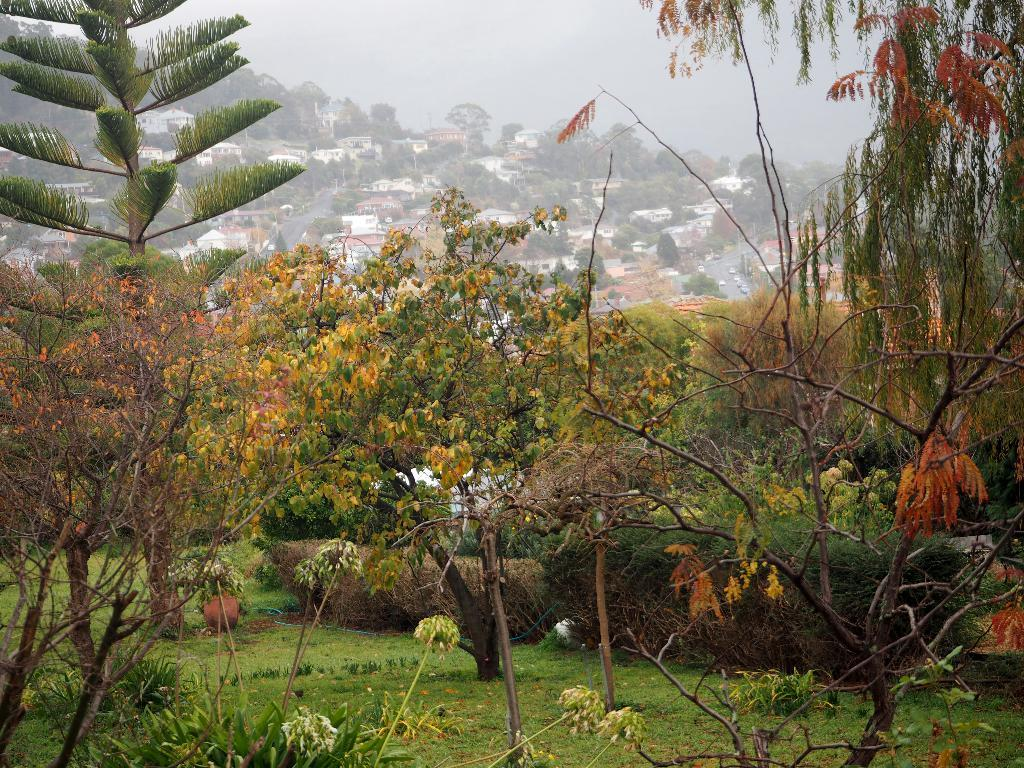What type of vegetation can be seen in the image? There are trees, plants, and grass in the image. What type of landscape feature is present in the image? There are hills in the image. Are there any man-made structures visible in the image? Yes, there are houses in the image. What is visible at the top of the image? The sky is visible at the top of the image. What type of square is depicted in the image? There is no square present in the image. What company is responsible for the landscaping in the image? The image does not provide information about the landscaping company. 